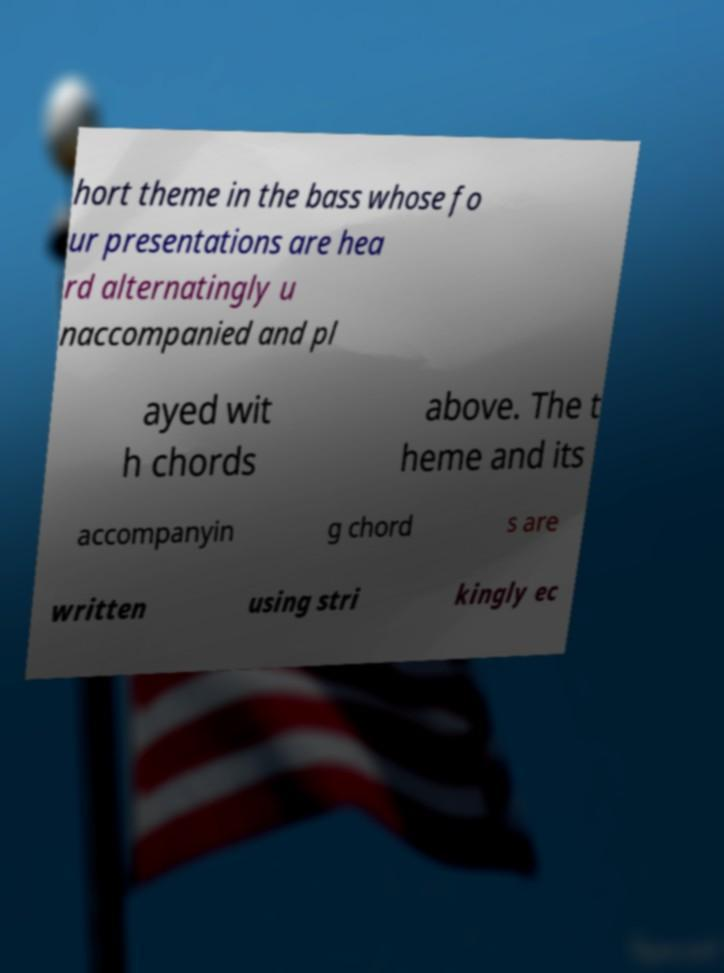Can you read and provide the text displayed in the image?This photo seems to have some interesting text. Can you extract and type it out for me? hort theme in the bass whose fo ur presentations are hea rd alternatingly u naccompanied and pl ayed wit h chords above. The t heme and its accompanyin g chord s are written using stri kingly ec 